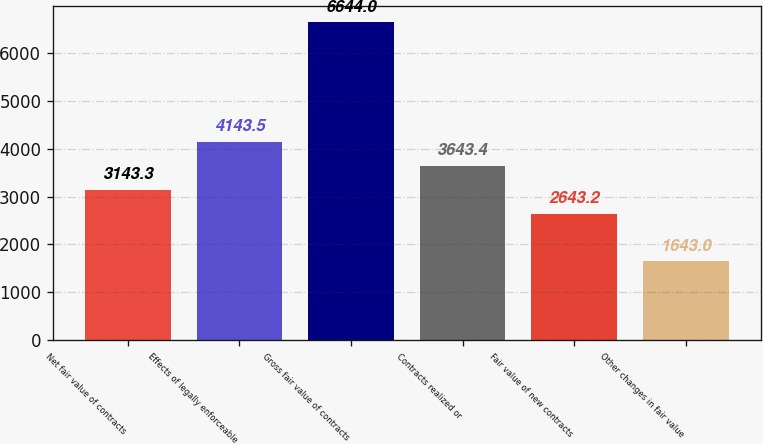Convert chart to OTSL. <chart><loc_0><loc_0><loc_500><loc_500><bar_chart><fcel>Net fair value of contracts<fcel>Effects of legally enforceable<fcel>Gross fair value of contracts<fcel>Contracts realized or<fcel>Fair value of new contracts<fcel>Other changes in fair value<nl><fcel>3143.3<fcel>4143.5<fcel>6644<fcel>3643.4<fcel>2643.2<fcel>1643<nl></chart> 